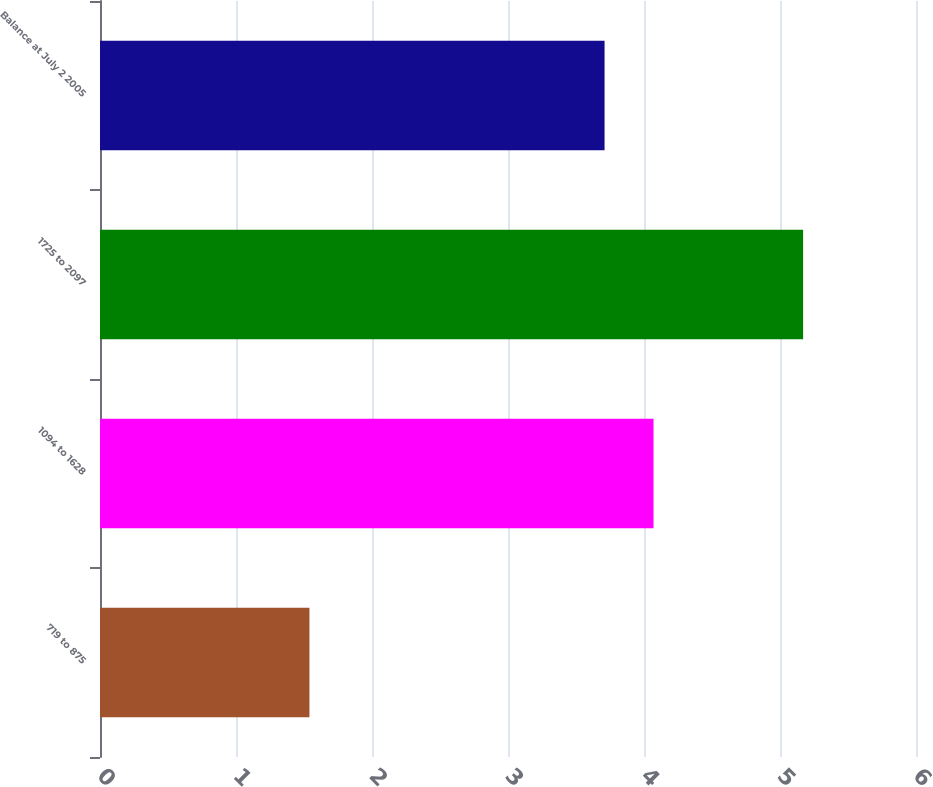<chart> <loc_0><loc_0><loc_500><loc_500><bar_chart><fcel>719 to 875<fcel>1094 to 1628<fcel>1725 to 2097<fcel>Balance at July 2 2005<nl><fcel>1.54<fcel>4.07<fcel>5.17<fcel>3.71<nl></chart> 